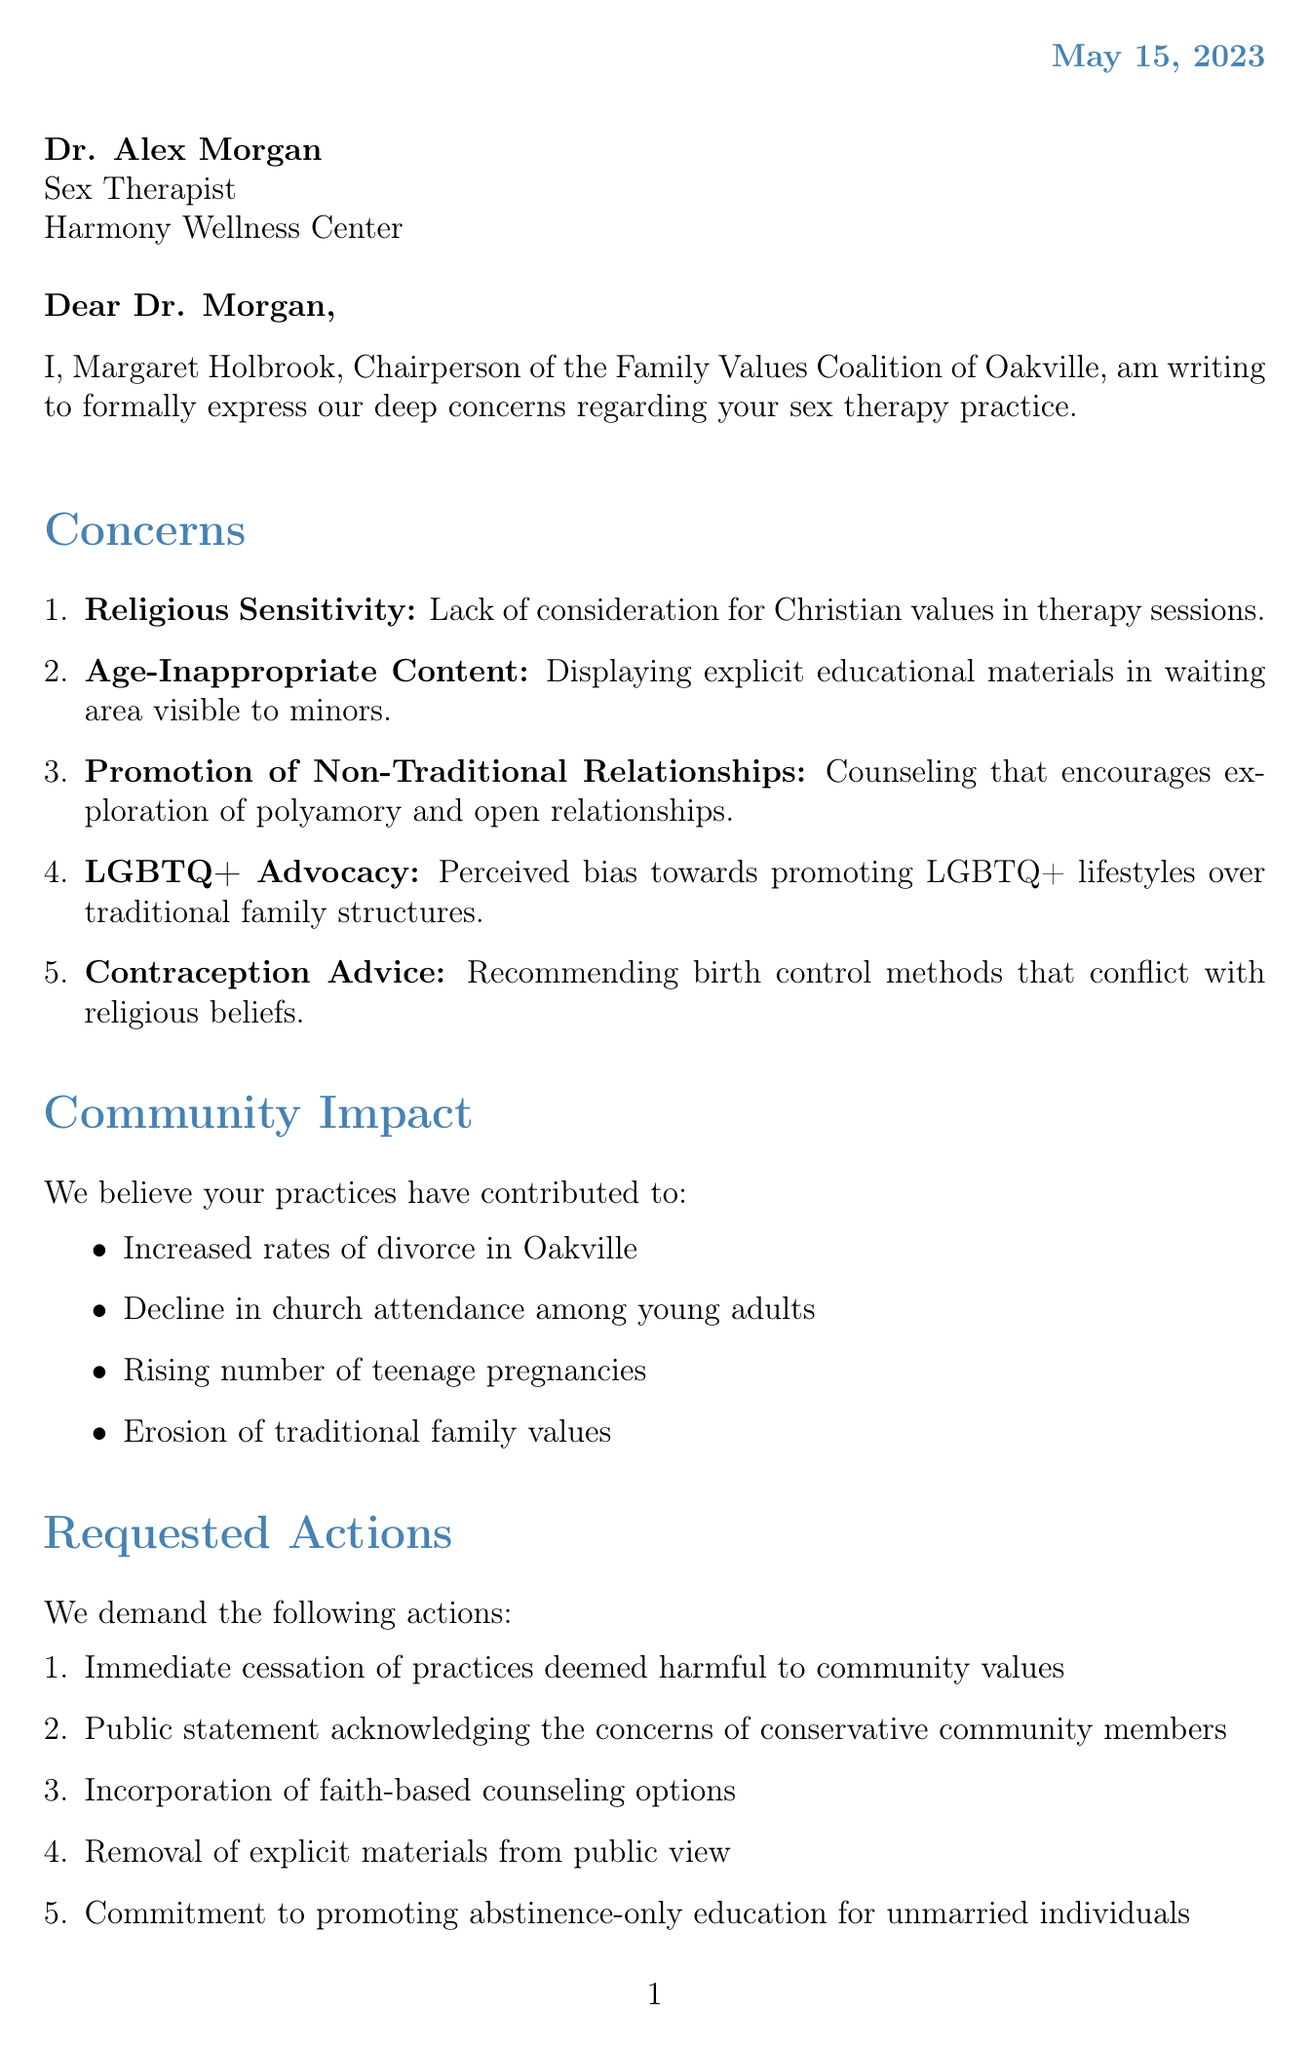What is the date of the letter? The date of the letter is explicitly mentioned in the document.
Answer: May 15, 2023 Who is the sender of the letter? The sender's name is provided in the document, identifying her position.
Answer: Margaret Holbrook What is one topic of concern mentioned in the letter? The letter lists multiple concerns, and one is specifically identified by its topic.
Answer: Religious sensitivity What community impact is mentioned regarding divorce rates? The letter indicates a specific issue linked to community practices.
Answer: Increased rates of divorce in Oakville What is one requested action from the Family Values Coalition? The letter clearly states multiple actions they demand.
Answer: Immediate cessation of practices deemed harmful to community values What legal action is threatened if concerns are not addressed? The document specifies the type of action anticipated based on responses to the complaint.
Answer: Legal action How many days are given to address the concerns? The letter details a specific timeline for response.
Answer: 30 days What is the recipient's title? The document clearly outlines the recipient's role in the practice.
Answer: Sex Therapist What is the closing statement of the letter? The letter concludes with a strong statement, which encapsulates the sender's request.
Answer: We urge you to consider the moral fabric of our community and adjust your practices accordingly 